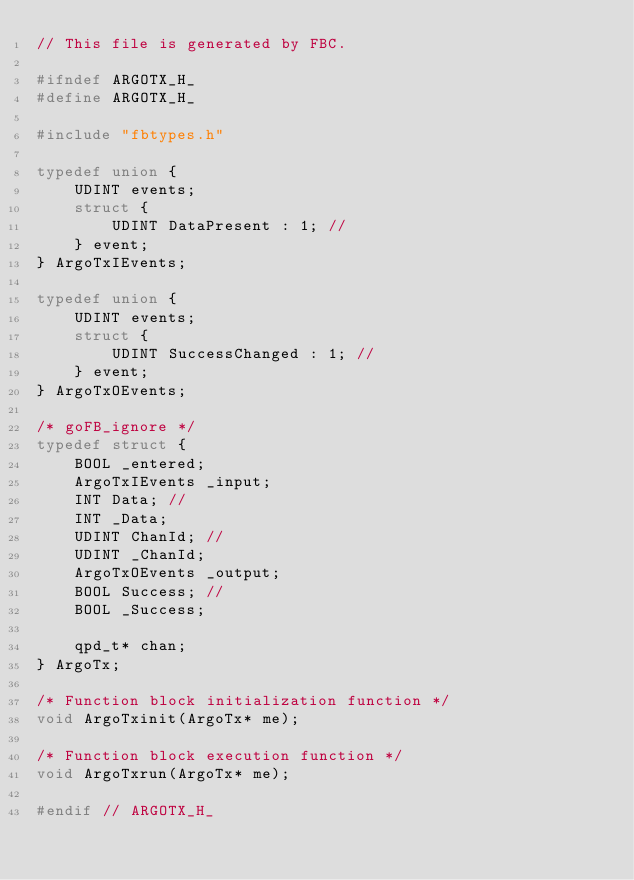<code> <loc_0><loc_0><loc_500><loc_500><_C_>// This file is generated by FBC.

#ifndef ARGOTX_H_
#define ARGOTX_H_

#include "fbtypes.h"

typedef union {
    UDINT events;
    struct {
        UDINT DataPresent : 1; // 
    } event;
} ArgoTxIEvents;

typedef union {
    UDINT events;
    struct {
        UDINT SuccessChanged : 1; // 
    } event;
} ArgoTxOEvents;

/* goFB_ignore */
typedef struct {
    BOOL _entered;
    ArgoTxIEvents _input;
    INT Data; // 
    INT _Data;
    UDINT ChanId; // 
    UDINT _ChanId;
    ArgoTxOEvents _output;
    BOOL Success; // 
    BOOL _Success;

		qpd_t* chan;
} ArgoTx;

/* Function block initialization function */
void ArgoTxinit(ArgoTx* me);

/* Function block execution function */
void ArgoTxrun(ArgoTx* me);

#endif // ARGOTX_H_
</code> 